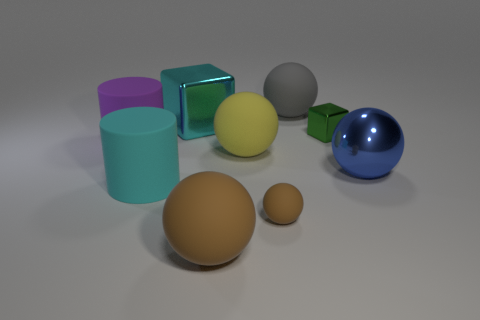There is another rubber object that is the same color as the tiny matte object; what is its shape?
Offer a very short reply. Sphere. The tiny sphere has what color?
Provide a succinct answer. Brown. Is there a rubber ball of the same color as the big shiny cube?
Your answer should be compact. No. There is a green metallic cube; is its size the same as the cyan thing in front of the blue shiny thing?
Ensure brevity in your answer.  No. What number of small objects are to the right of the brown matte sphere to the right of the object in front of the tiny brown ball?
Ensure brevity in your answer.  1. There is another thing that is the same color as the small rubber thing; what size is it?
Keep it short and to the point. Large. There is a cyan shiny cube; are there any big gray rubber spheres in front of it?
Make the answer very short. No. The blue object is what shape?
Give a very brief answer. Sphere. There is a small object that is in front of the big metal object that is to the right of the metallic block on the left side of the tiny green object; what is its shape?
Make the answer very short. Sphere. How many other things are there of the same shape as the large gray matte object?
Give a very brief answer. 4. 